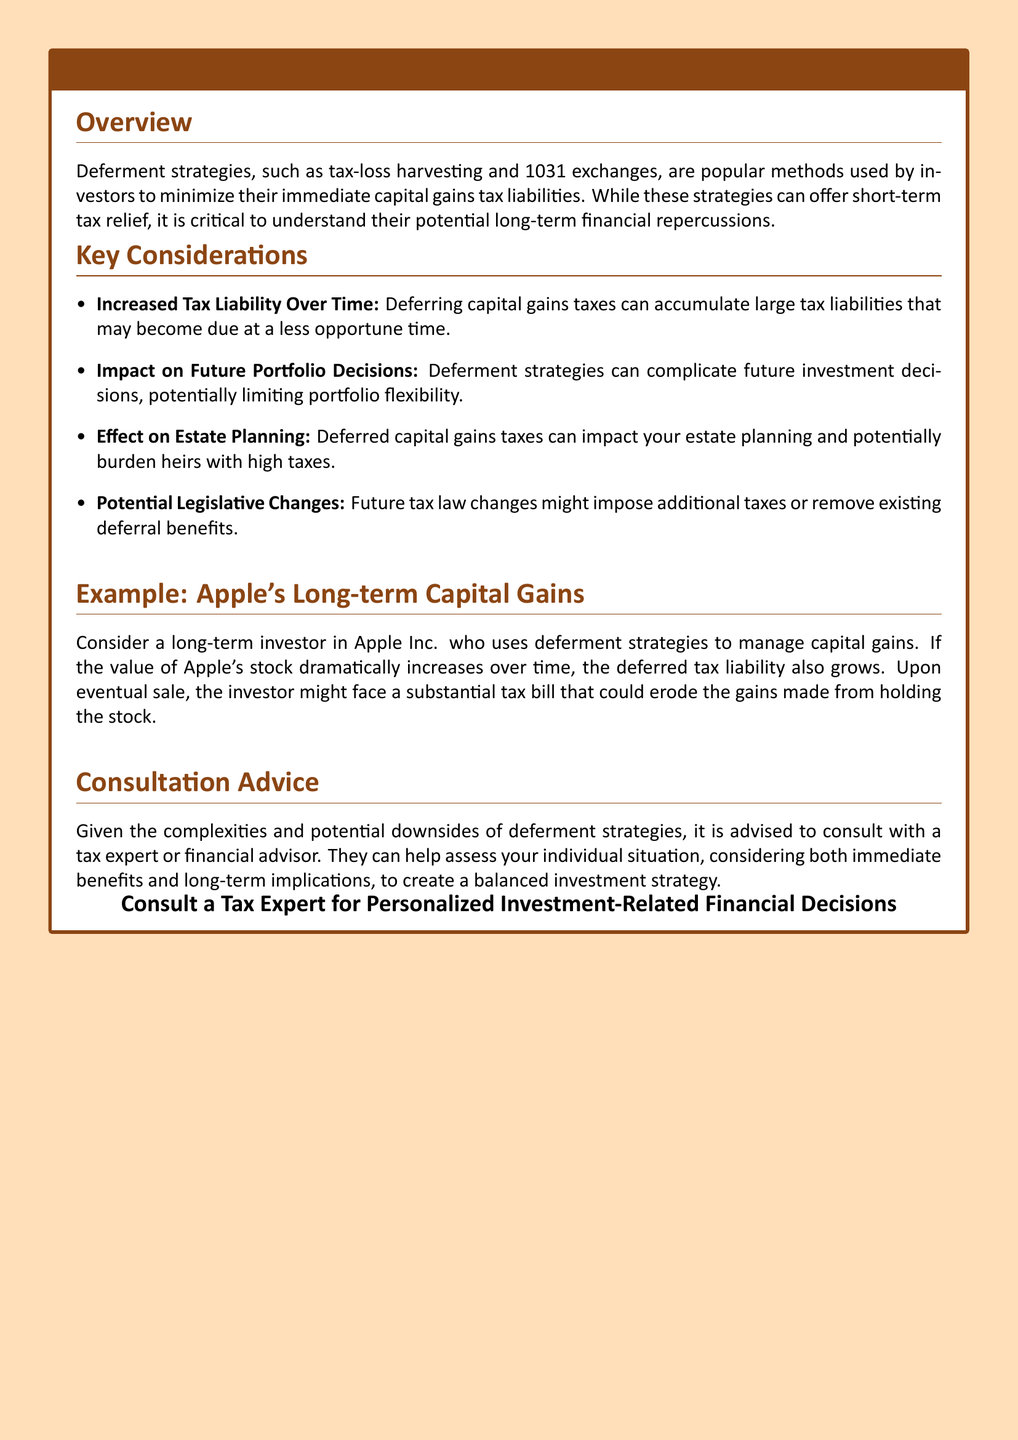What are deferment strategies? Deferment strategies are methods used by investors to minimize their immediate capital gains tax liabilities.
Answer: Methods used to minimize tax liabilities What example is provided in the document? The document uses Apple Inc. as a long-term investment example to discuss deferment strategies.
Answer: Apple's Long-term Capital Gains What is one potential downside of deferment strategies? One downside mentioned is that deferring capital gains taxes can accumulate large tax liabilities.
Answer: Increased Tax Liability Over Time Who should you consult regarding deferment strategies? The document advises consulting with a tax expert or financial advisor regarding deferment strategies.
Answer: Tax expert or financial advisor What can complicate future investment decisions? Deferment strategies can complicate future investment decisions.
Answer: Deferment strategies What is one potential impact of deferred capital gains taxes on heirs? Deferred capital gains taxes can potentially burden heirs with high taxes.
Answer: Burden heirs with high taxes What is the color used for the warning label background? The background color for the warning label is a light yellowish shade, defined as warningcolor.
Answer: Warningcolor How can deferred tax liabilities affect an investor? As the value of an investment increases, deferred tax liabilities can also grow, leading to a substantial tax bill upon sale.
Answer: Substantial tax bill upon sale 